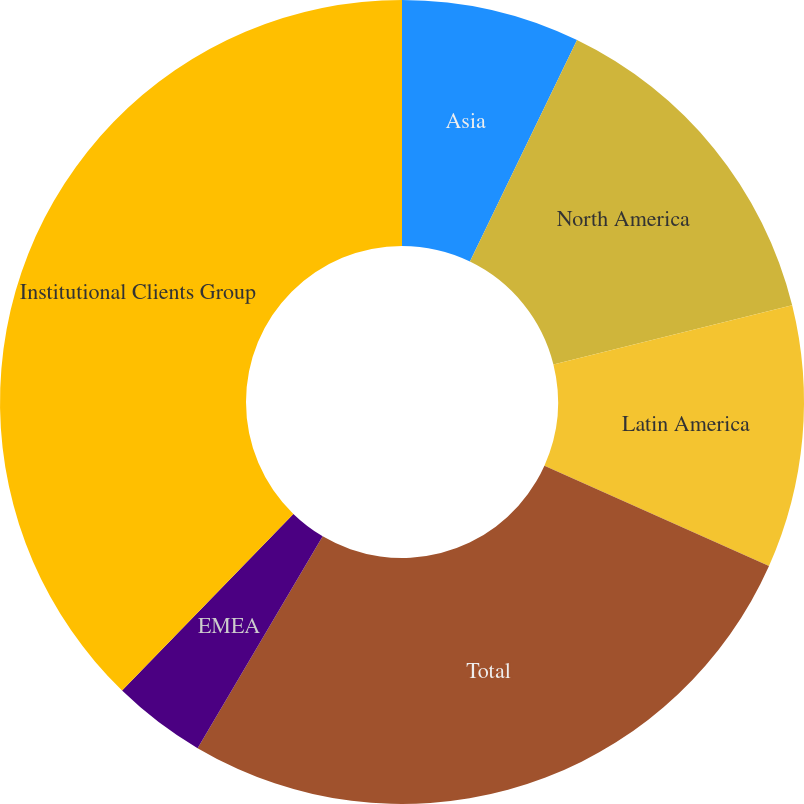Convert chart. <chart><loc_0><loc_0><loc_500><loc_500><pie_chart><fcel>Asia<fcel>North America<fcel>Latin America<fcel>Total<fcel>EMEA<fcel>Institutional Clients Group<nl><fcel>7.17%<fcel>13.96%<fcel>10.56%<fcel>26.8%<fcel>3.77%<fcel>37.74%<nl></chart> 